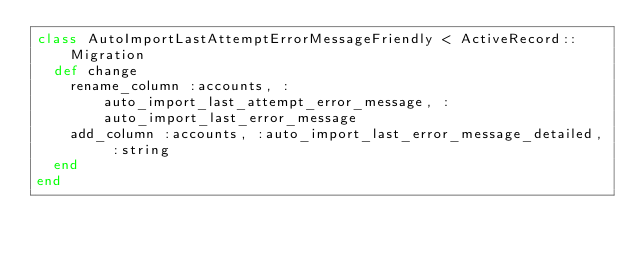<code> <loc_0><loc_0><loc_500><loc_500><_Ruby_>class AutoImportLastAttemptErrorMessageFriendly < ActiveRecord::Migration
  def change
  	rename_column :accounts, :auto_import_last_attempt_error_message, :auto_import_last_error_message
  	add_column :accounts, :auto_import_last_error_message_detailed, :string
  end
end
</code> 